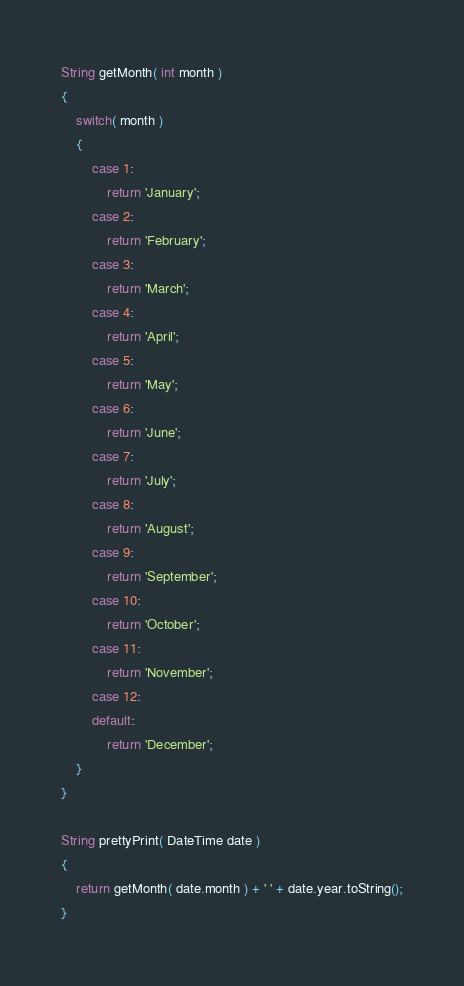<code> <loc_0><loc_0><loc_500><loc_500><_Dart_>String getMonth( int month )
{
	switch( month )
	{
		case 1:
			return 'January';
		case 2:
			return 'February';
		case 3:
			return 'March';
		case 4:
			return 'April';
		case 5:
			return 'May';
		case 6:
			return 'June';
		case 7:
			return 'July';
		case 8:
			return 'August';
		case 9:
			return 'September';
		case 10:
			return 'October';
		case 11:
			return 'November';
		case 12:
		default:
			return 'December';
	}
}

String prettyPrint( DateTime date )
{
	return getMonth( date.month ) + ' ' + date.year.toString();
}</code> 